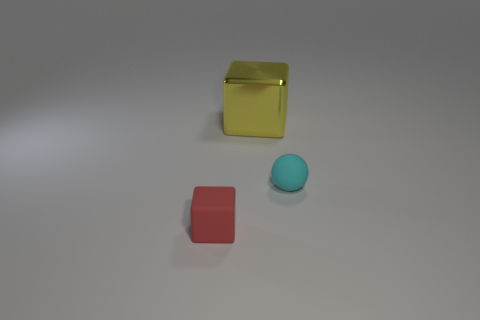Add 2 tiny yellow rubber cylinders. How many objects exist? 5 Subtract all blocks. How many objects are left? 1 Add 1 tiny red matte blocks. How many tiny red matte blocks are left? 2 Add 1 small blue cubes. How many small blue cubes exist? 1 Subtract 0 blue cylinders. How many objects are left? 3 Subtract all big yellow cubes. Subtract all rubber cubes. How many objects are left? 1 